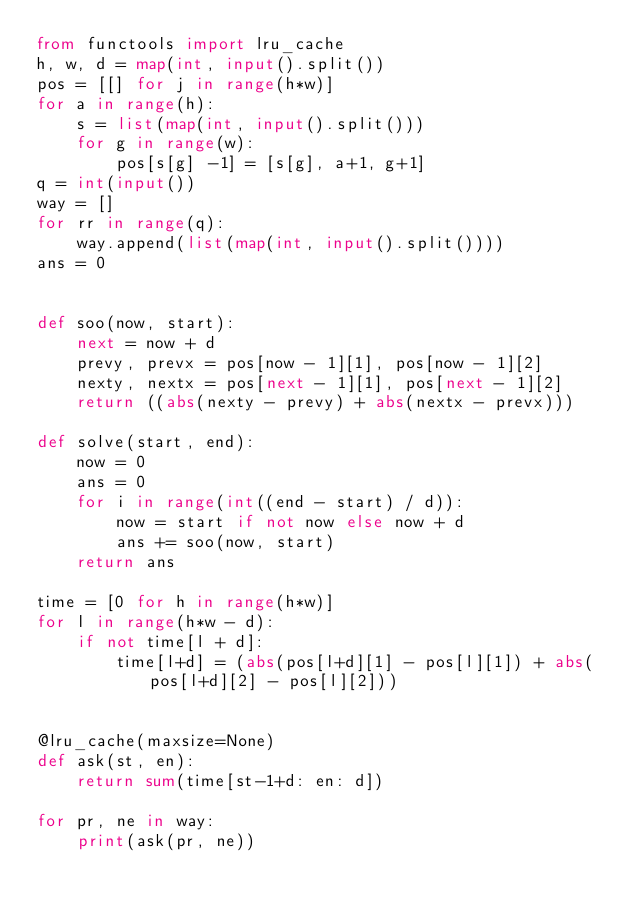Convert code to text. <code><loc_0><loc_0><loc_500><loc_500><_Python_>from functools import lru_cache
h, w, d = map(int, input().split())
pos = [[] for j in range(h*w)]
for a in range(h):
    s = list(map(int, input().split()))
    for g in range(w):
        pos[s[g] -1] = [s[g], a+1, g+1]
q = int(input())
way = []
for rr in range(q):
    way.append(list(map(int, input().split())))
ans = 0


def soo(now, start):
    next = now + d
    prevy, prevx = pos[now - 1][1], pos[now - 1][2]
    nexty, nextx = pos[next - 1][1], pos[next - 1][2]
    return ((abs(nexty - prevy) + abs(nextx - prevx)))

def solve(start, end):
    now = 0
    ans = 0
    for i in range(int((end - start) / d)):
        now = start if not now else now + d
        ans += soo(now, start)
    return ans

time = [0 for h in range(h*w)]
for l in range(h*w - d):
    if not time[l + d]:
        time[l+d] = (abs(pos[l+d][1] - pos[l][1]) + abs(pos[l+d][2] - pos[l][2]))


@lru_cache(maxsize=None)
def ask(st, en):
    return sum(time[st-1+d: en: d])

for pr, ne in way:
    print(ask(pr, ne))</code> 